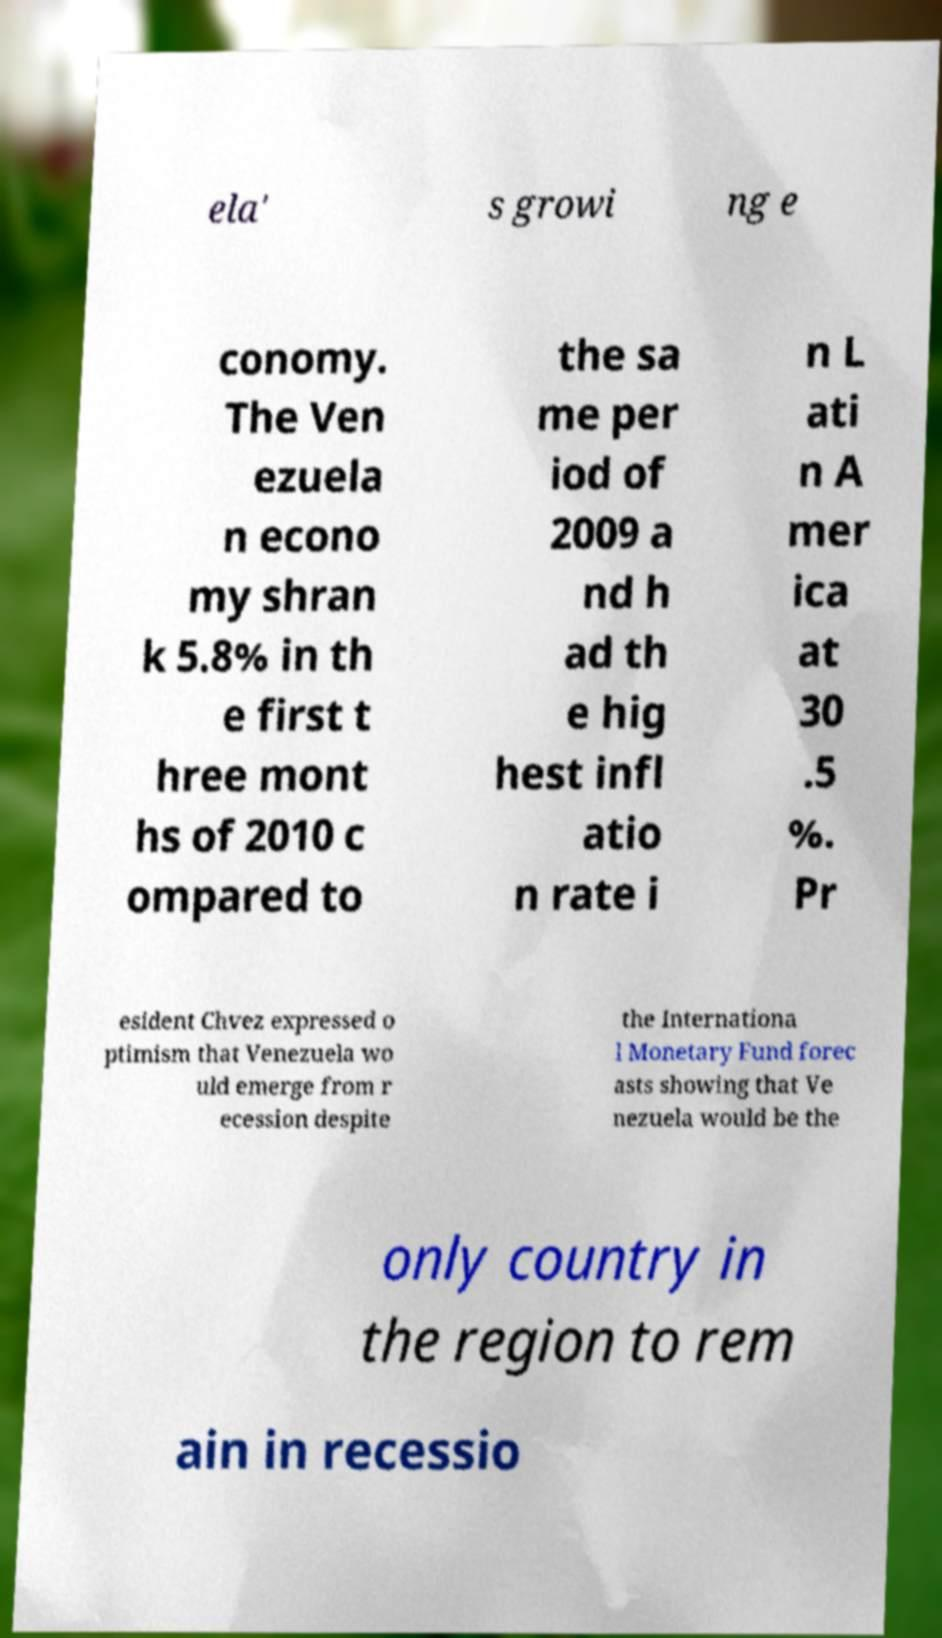Please identify and transcribe the text found in this image. ela' s growi ng e conomy. The Ven ezuela n econo my shran k 5.8% in th e first t hree mont hs of 2010 c ompared to the sa me per iod of 2009 a nd h ad th e hig hest infl atio n rate i n L ati n A mer ica at 30 .5 %. Pr esident Chvez expressed o ptimism that Venezuela wo uld emerge from r ecession despite the Internationa l Monetary Fund forec asts showing that Ve nezuela would be the only country in the region to rem ain in recessio 